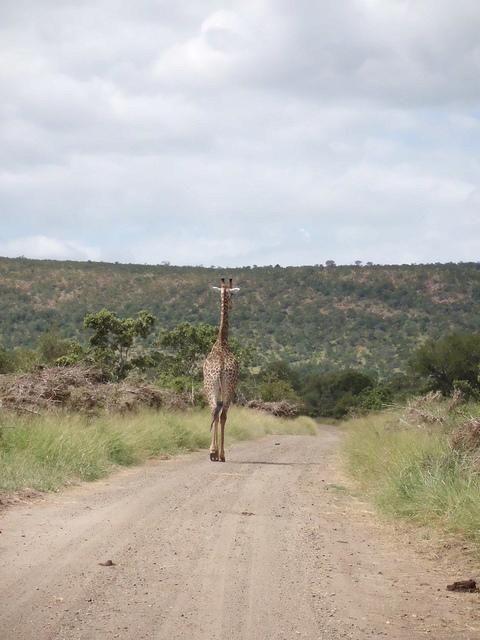How many vehicles are in view?
Give a very brief answer. 0. How many giraffes are visible?
Give a very brief answer. 1. How many vases are there?
Give a very brief answer. 0. 